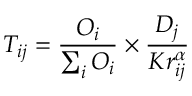Convert formula to latex. <formula><loc_0><loc_0><loc_500><loc_500>T _ { i j } = \frac { O _ { i } } { \sum _ { i } O _ { i } } \times \frac { D _ { j } } { K r _ { i j } ^ { \alpha } }</formula> 